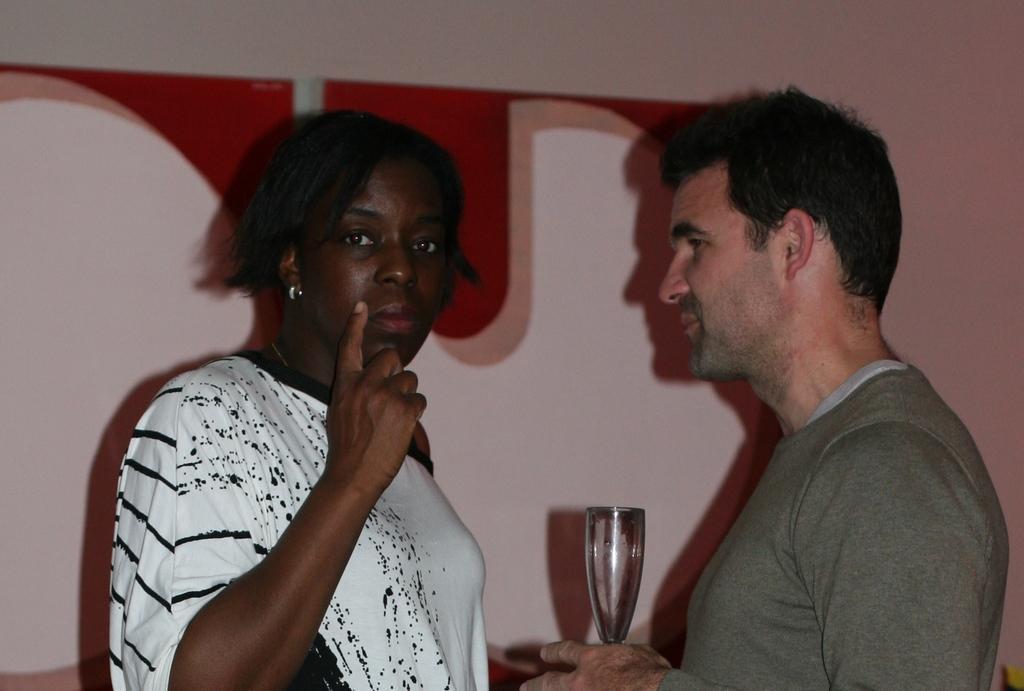Describe this image in one or two sentences. In this image, On the right side there is a man standing and he is holding a glass in his hand and on the left side there is a woman standing and she is raising her hand and she is showing a finger, In the background there is a wall of red and white color. 